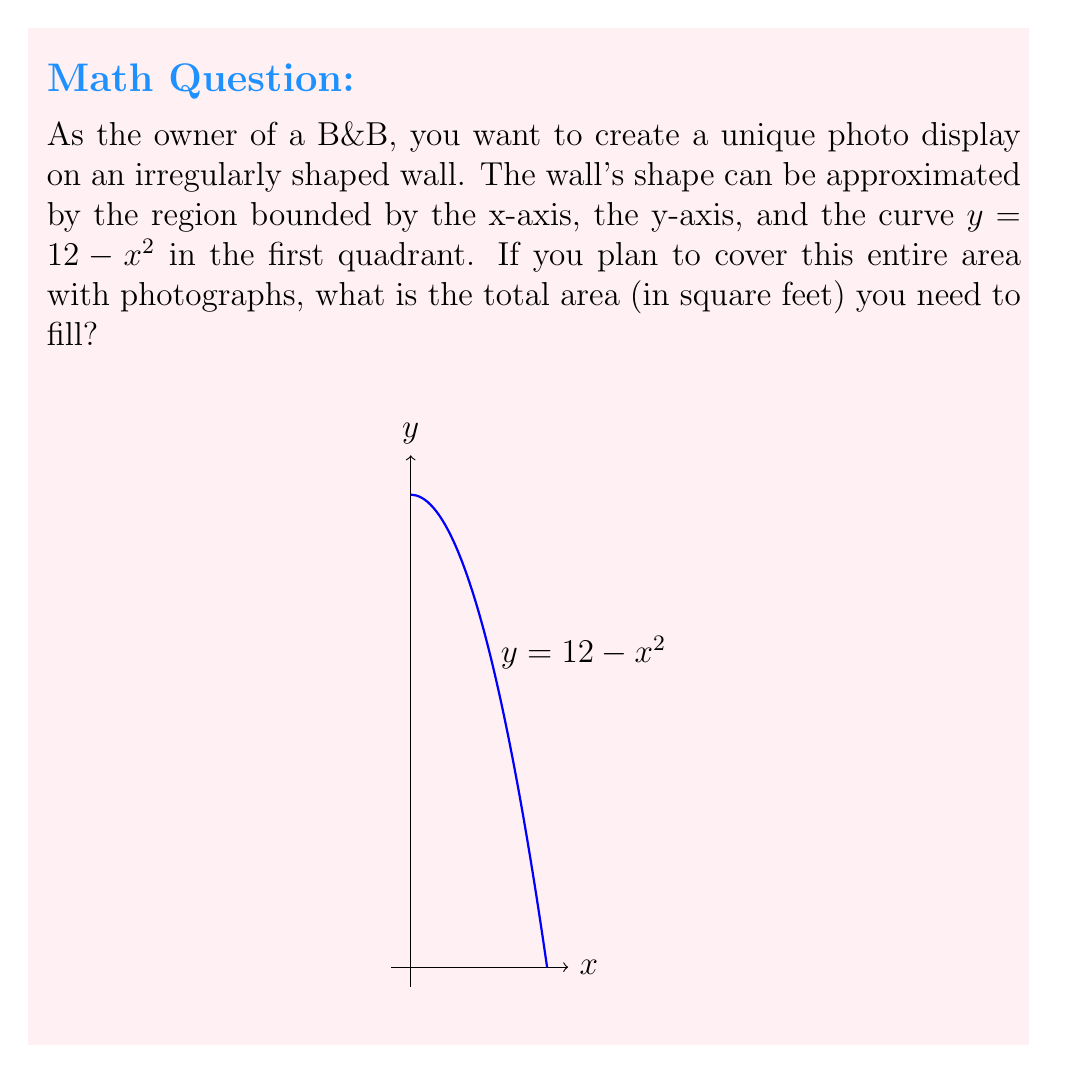Teach me how to tackle this problem. To find the area of this irregular shape, we need to use integral calculus. The steps are as follows:

1) The area is bounded by the x-axis, y-axis, and the curve $y = 12 - x^2$.

2) The curve intersects the x-axis when $12 - x^2 = 0$, or $x = \sqrt{12} = 2\sqrt{3}$.

3) To find the area, we need to integrate the function from 0 to $2\sqrt{3}$:

   $$A = \int_0^{2\sqrt{3}} (12 - x^2) dx$$

4) Let's solve this integral:
   
   $$A = [12x - \frac{1}{3}x^3]_0^{2\sqrt{3}}$$

5) Evaluating the bounds:

   $$A = (12(2\sqrt{3}) - \frac{1}{3}(2\sqrt{3})^3) - (12(0) - \frac{1}{3}(0)^3)$$

6) Simplify:

   $$A = 24\sqrt{3} - \frac{8}{3}(3\sqrt{3}) = 24\sqrt{3} - 8\sqrt{3} = 16\sqrt{3}$$

7) Therefore, the area is $16\sqrt{3}$ square feet.
Answer: $16\sqrt{3}$ sq ft 